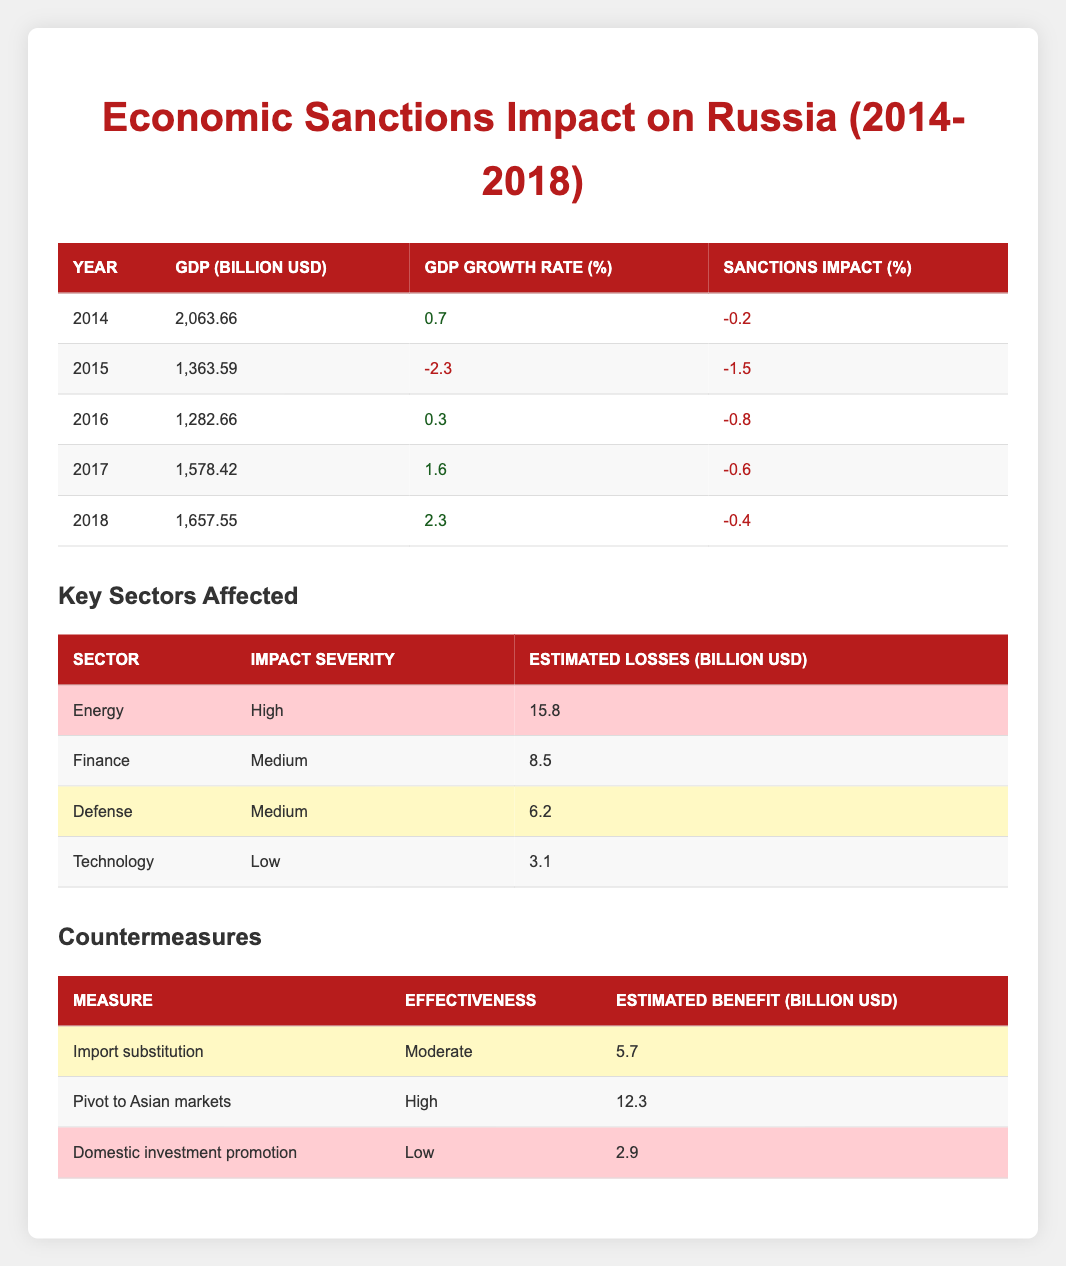What was the GDP (in billion USD) for Russia in 2014? Referring to the table, the GDP for Russia in 2014 is found in the corresponding row under the "GDP (Billion USD)" column.
Answer: 2063.66 What was the GDP growth rate for Russia in 2016? Looking at the table for the year 2016, the GDP growth rate is listed under the "GDP Growth Rate (%)" column.
Answer: 0.3 What is the total estimated loss in the Energy sector due to sanctions? The table for key sectors affected shows the estimated loss in the Energy sector as 15.8 billion USD, which is a direct retrieval of that specific value.
Answer: 15.8 What is the average GDP value of Russia from 2014 to 2018? To find the average GDP, first sum the values of GDP from each year: (2063.66 + 1363.59 + 1282.66 + 1578.42 + 1657.55) = 6,946.88 billion USD. Then divide by the number of years (5): 6,946.88 / 5 = 1389.376.
Answer: 1389.38 Did the sanctions impact Russia's GDP growth in each year from 2014 to 2018? Yes, each year listed shows a negative impact percentage due to sanctions, indicating that the sanctions affected GDP growth every year.
Answer: Yes What was the effectiveness rating of the "Domestic investment promotion" countermeasure? The table lists the effectiveness of "Domestic investment promotion" as "Low." This is a straightforward retrieval from the data.
Answer: Low How much did the GDP decline from 2014 to 2015? The GDP in 2014 was 2063.66 billion USD, and in 2015 it was 1363.59 billion USD. The decline is calculated as 2063.66 - 1363.59 = 700.07 billion USD.
Answer: 700.07 Which sector had the highest estimated losses due to sanctions? The table indicates that the Energy sector had the highest estimated losses of 15.8 billion USD, as shown in the column for estimated losses.
Answer: Energy What is the combined estimated benefit from both "Pivot to Asian markets" and "Import substitution" measures? The estimated benefit from "Pivot to Asian markets" is 12.3 billion USD, and from "Import substitution," it is 5.7 billion USD. Adding these gives: 12.3 + 5.7 = 18 billion USD.
Answer: 18 